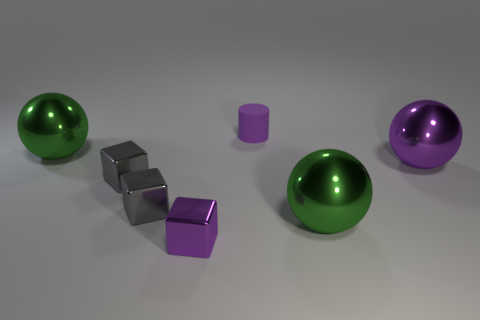Add 2 big spheres. How many objects exist? 9 Subtract all cylinders. How many objects are left? 6 Subtract 0 blue balls. How many objects are left? 7 Subtract all gray rubber spheres. Subtract all tiny gray shiny objects. How many objects are left? 5 Add 6 green things. How many green things are left? 8 Add 2 small brown blocks. How many small brown blocks exist? 2 